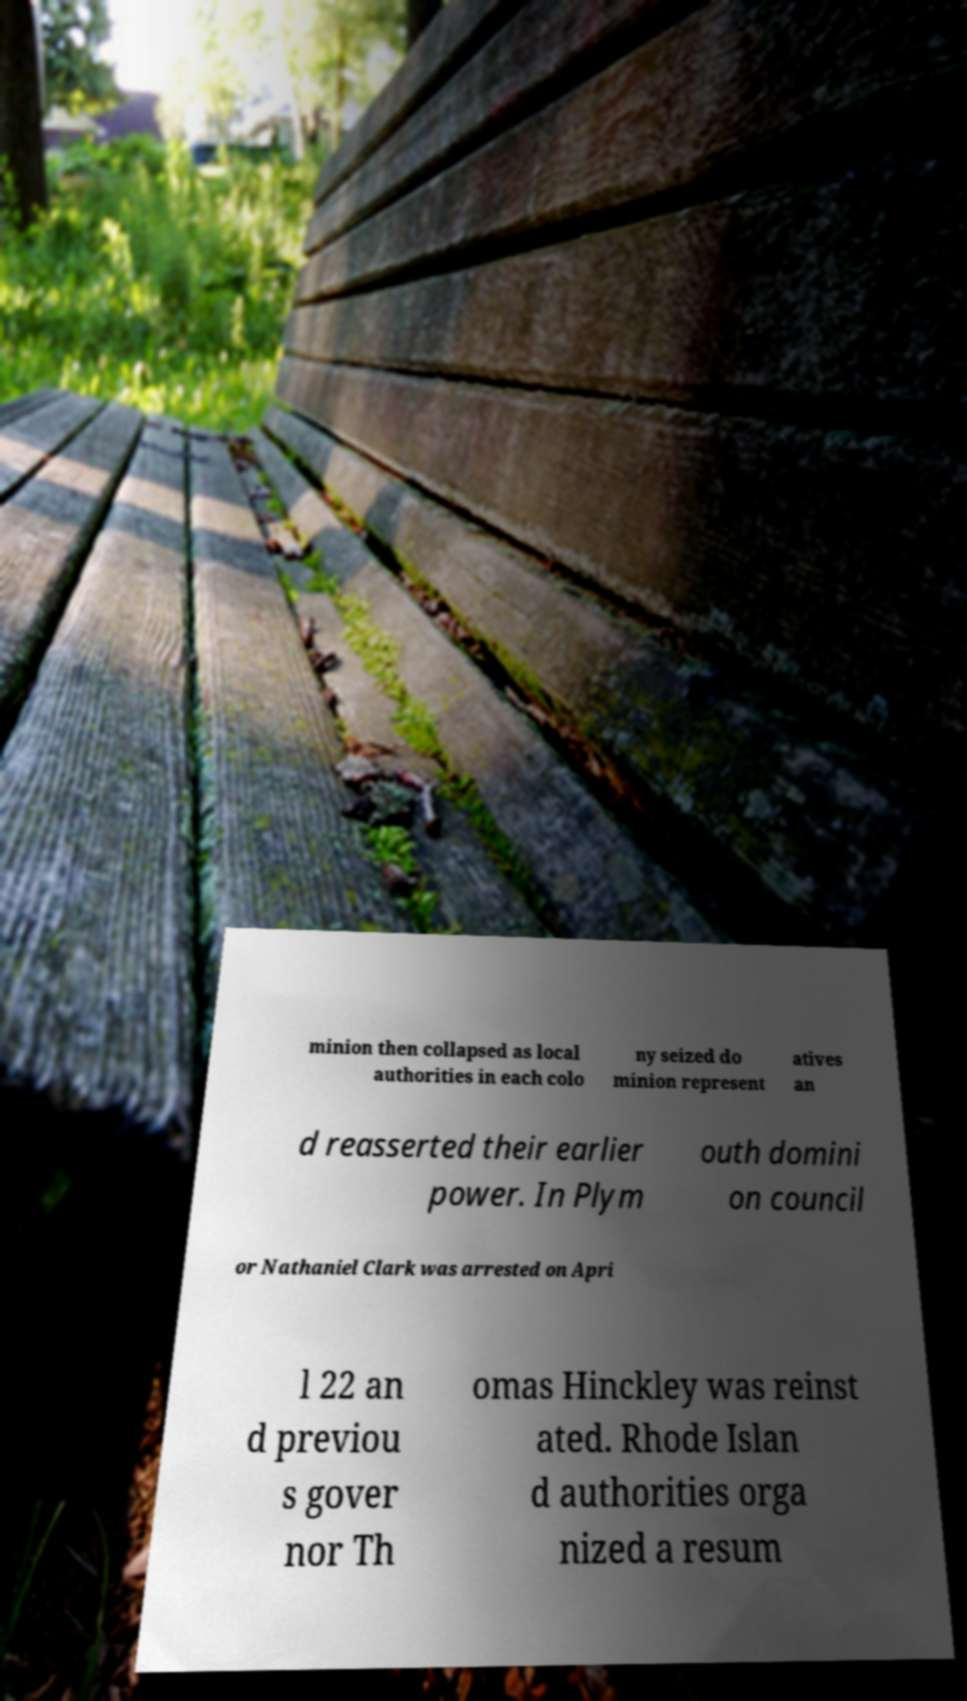Can you accurately transcribe the text from the provided image for me? minion then collapsed as local authorities in each colo ny seized do minion represent atives an d reasserted their earlier power. In Plym outh domini on council or Nathaniel Clark was arrested on Apri l 22 an d previou s gover nor Th omas Hinckley was reinst ated. Rhode Islan d authorities orga nized a resum 